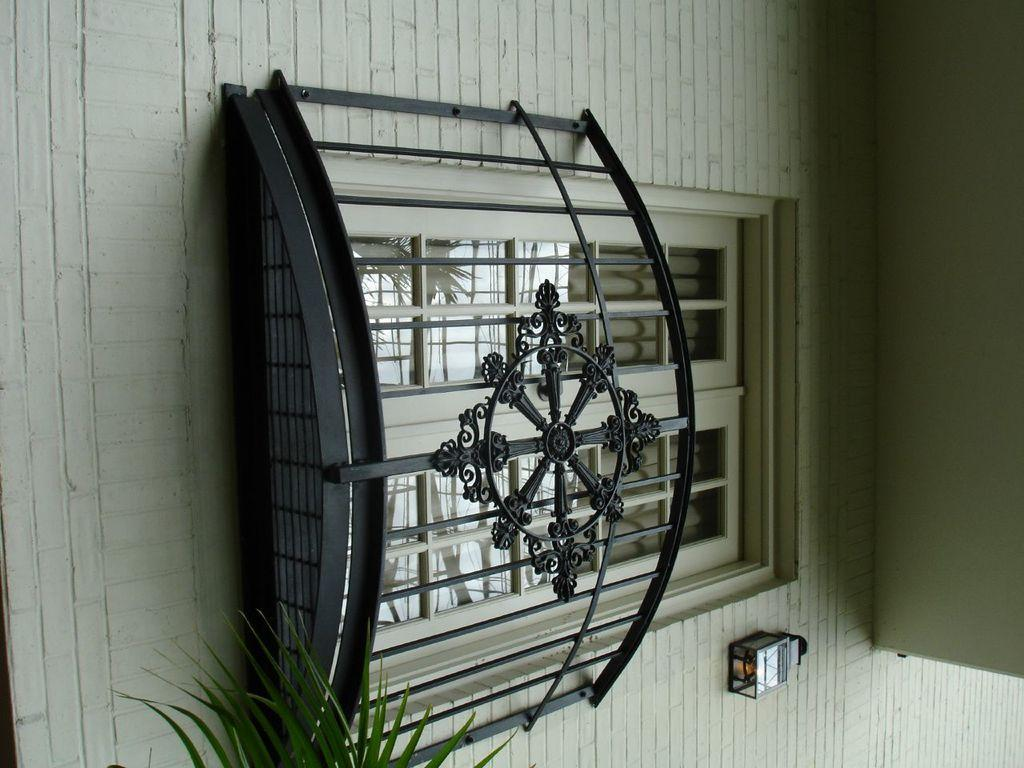What type of structure is present in the middle of the image? There is a glass window in the middle of the image. What is located at the bottom of the image? There are leaves at the bottom of the image. How does the crook help the person in the image? There is no crook or person present in the image, so it is not possible to determine how a crook might help someone. 